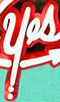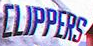What words are shown in these images in order, separated by a semicolon? yes; CLIPPERS 